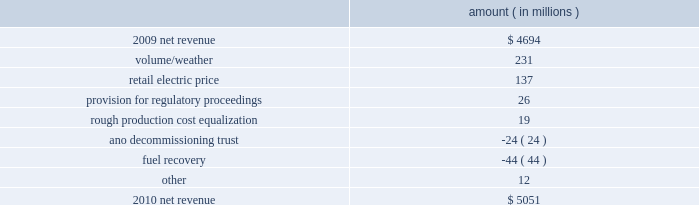Entergy corporation and subsidiaries management's financial discussion and analysis refer to 201cselected financial data - five-year comparison of entergy corporation and subsidiaries 201d which accompanies entergy corporation 2019s financial statements in this report for further information with respect to operating statistics .
In november 2007 the board approved a plan to pursue a separation of entergy 2019s non-utility nuclear business from entergy through a spin-off of the business to entergy shareholders .
In april 2010 , entergy announced that it planned to unwind the business infrastructure associated with the proposed spin-off transaction .
As a result of the plan to unwind the business infrastructure , entergy recorded expenses in 2010 for the write-off of certain capitalized costs incurred in connection with the planned spin-off transaction .
These costs are discussed in more detail below and throughout this section .
Net revenue utility following is an analysis of the change in net revenue comparing 2010 to 2009 .
Amount ( in millions ) .
The volume/weather variance is primarily due to an increase of 8362 gwh , or 8% ( 8 % ) , in billed electricity usage in all retail sectors , including the effect on the residential sector of colder weather in the first quarter 2010 compared to 2009 and warmer weather in the second and third quarters 2010 compared to 2009 .
The industrial sector reflected strong sales growth on continuing signs of economic recovery .
The improvement in this sector was primarily driven by inventory restocking and strong exports with the chemicals , refining , and miscellaneous manufacturing sectors leading the improvement .
The retail electric price variance is primarily due to : increases in the formula rate plan riders at entergy gulf states louisiana effective november 2009 , january 2010 , and september 2010 , at entergy louisiana effective november 2009 , and at entergy mississippi effective july 2009 ; a base rate increase at entergy arkansas effective july 2010 ; rate actions at entergy texas , including base rate increases effective in may and august 2010 ; a formula rate plan provision of $ 16.6 million recorded in the third quarter 2009 for refunds that were made to customers in accordance with settlements approved by the lpsc ; and the recovery in 2009 by entergy arkansas of 2008 extraordinary storm costs , as approved by the apsc , which ceased in january 2010 .
The recovery of storm costs is offset in other operation and maintenance expenses .
See note 2 to the financial statements for further discussion of the proceedings referred to above. .
What is the net change in amount of net revenue from 2009 to 2010? 
Computations: (5051 - 4694)
Answer: 357.0. Entergy corporation and subsidiaries management's financial discussion and analysis refer to 201cselected financial data - five-year comparison of entergy corporation and subsidiaries 201d which accompanies entergy corporation 2019s financial statements in this report for further information with respect to operating statistics .
In november 2007 the board approved a plan to pursue a separation of entergy 2019s non-utility nuclear business from entergy through a spin-off of the business to entergy shareholders .
In april 2010 , entergy announced that it planned to unwind the business infrastructure associated with the proposed spin-off transaction .
As a result of the plan to unwind the business infrastructure , entergy recorded expenses in 2010 for the write-off of certain capitalized costs incurred in connection with the planned spin-off transaction .
These costs are discussed in more detail below and throughout this section .
Net revenue utility following is an analysis of the change in net revenue comparing 2010 to 2009 .
Amount ( in millions ) .
The volume/weather variance is primarily due to an increase of 8362 gwh , or 8% ( 8 % ) , in billed electricity usage in all retail sectors , including the effect on the residential sector of colder weather in the first quarter 2010 compared to 2009 and warmer weather in the second and third quarters 2010 compared to 2009 .
The industrial sector reflected strong sales growth on continuing signs of economic recovery .
The improvement in this sector was primarily driven by inventory restocking and strong exports with the chemicals , refining , and miscellaneous manufacturing sectors leading the improvement .
The retail electric price variance is primarily due to : increases in the formula rate plan riders at entergy gulf states louisiana effective november 2009 , january 2010 , and september 2010 , at entergy louisiana effective november 2009 , and at entergy mississippi effective july 2009 ; a base rate increase at entergy arkansas effective july 2010 ; rate actions at entergy texas , including base rate increases effective in may and august 2010 ; a formula rate plan provision of $ 16.6 million recorded in the third quarter 2009 for refunds that were made to customers in accordance with settlements approved by the lpsc ; and the recovery in 2009 by entergy arkansas of 2008 extraordinary storm costs , as approved by the apsc , which ceased in january 2010 .
The recovery of storm costs is offset in other operation and maintenance expenses .
See note 2 to the financial statements for further discussion of the proceedings referred to above. .
What was the percentage change of the net revenue in 2010? 
Computations: ((5051 - 4694) / 4694)
Answer: 0.07605. 